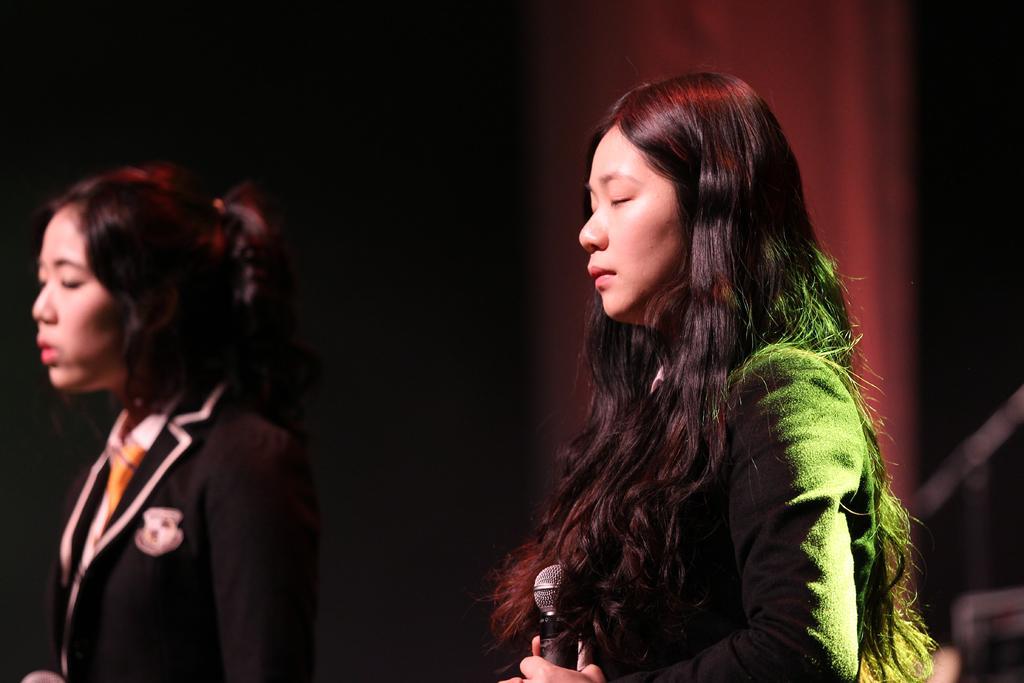How would you summarize this image in a sentence or two? In this image I can see two women closing their eyes and facing towards the left side. The woman who is on the right side is holding a mike in the hand. The background is blurred. 